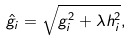Convert formula to latex. <formula><loc_0><loc_0><loc_500><loc_500>\hat { g } _ { i } = \sqrt { g _ { i } ^ { 2 } + \lambda h _ { i } ^ { 2 } } ,</formula> 